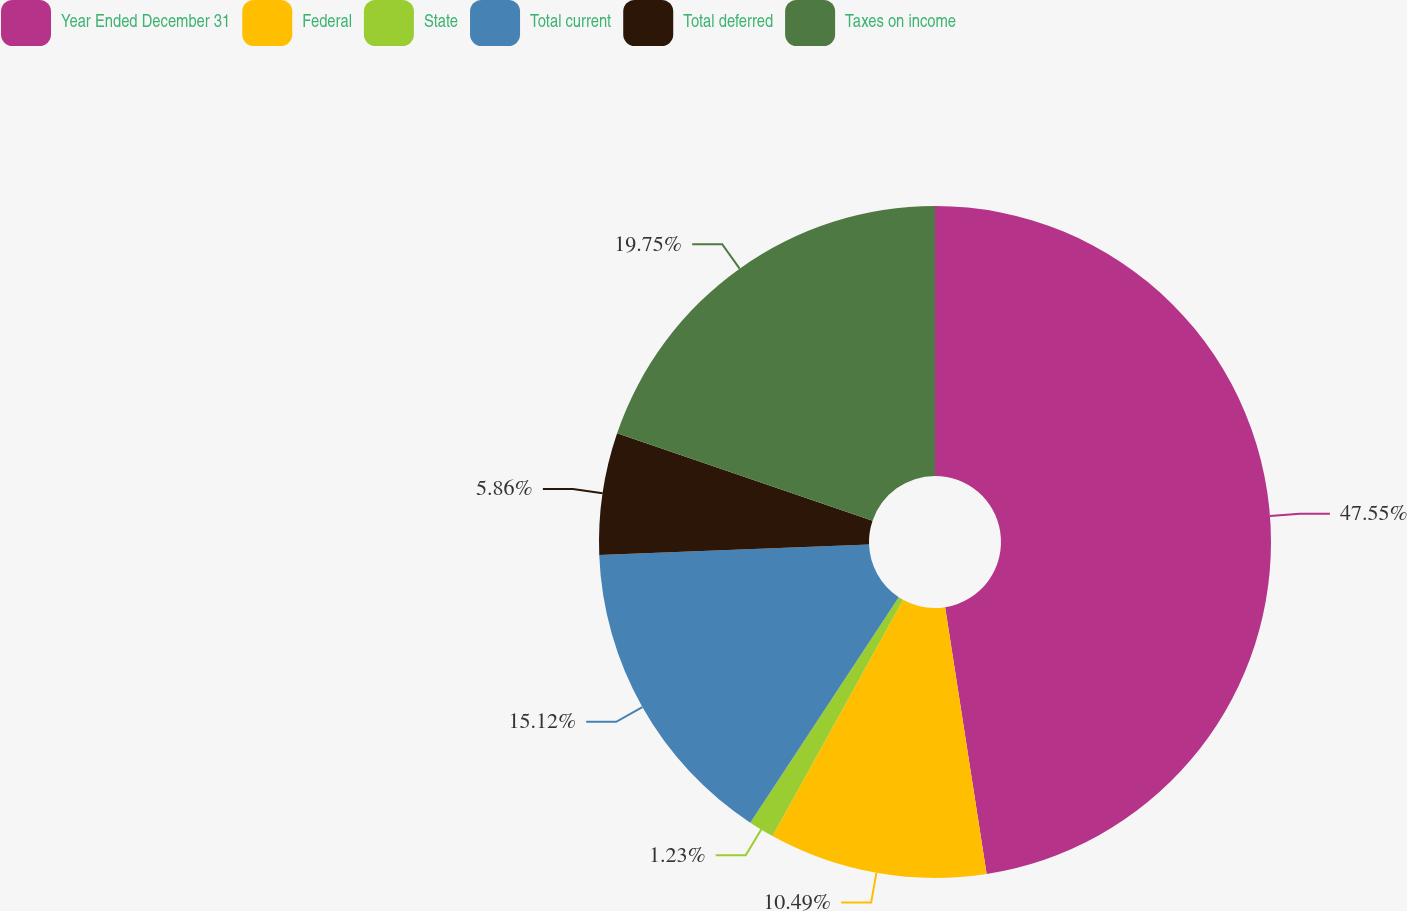Convert chart to OTSL. <chart><loc_0><loc_0><loc_500><loc_500><pie_chart><fcel>Year Ended December 31<fcel>Federal<fcel>State<fcel>Total current<fcel>Total deferred<fcel>Taxes on income<nl><fcel>47.54%<fcel>10.49%<fcel>1.23%<fcel>15.12%<fcel>5.86%<fcel>19.75%<nl></chart> 